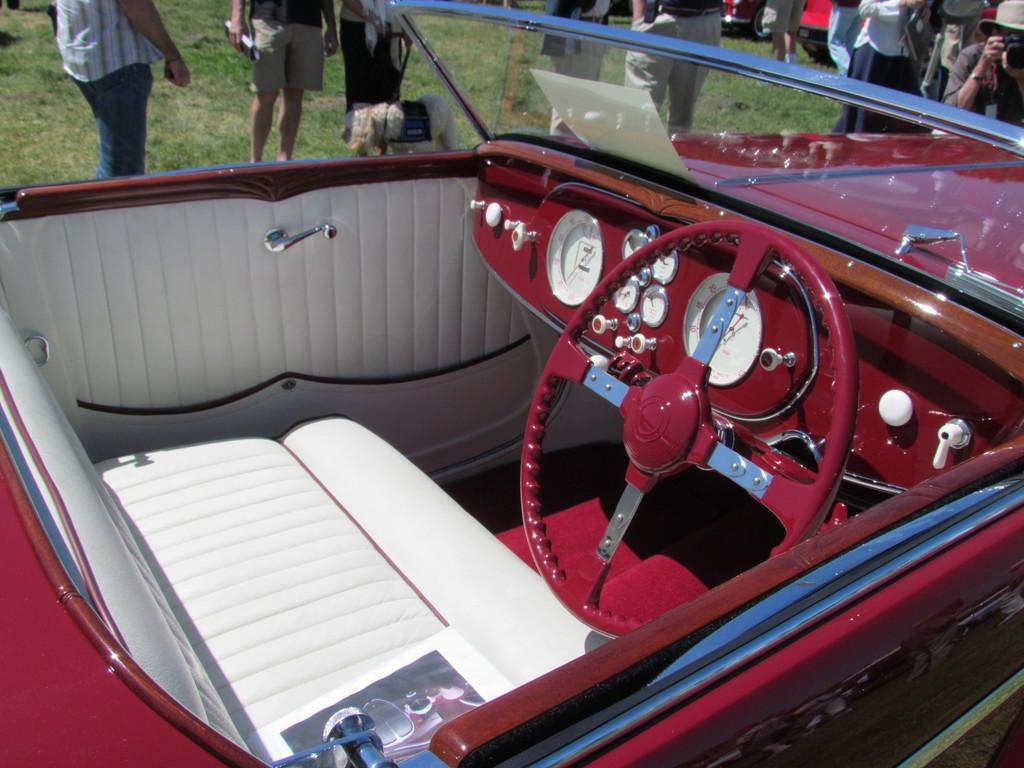What can be seen in the image related to transportation? There are vehicles in the image. What is the group of people doing in the image? The group of people is standing on the grass. Can you describe the man's attire in the image? The man is wearing a cap. What is the man holding in the image? The man is holding a camera with his hands. What else can be seen in the image besides the vehicles and people? There are some objects in the image. Is there any humor depicted in the image? There is no indication of humor in the image based on the provided facts. Is there an umbrella visible in the image? There is no mention of an umbrella in the image based on the provided facts. 